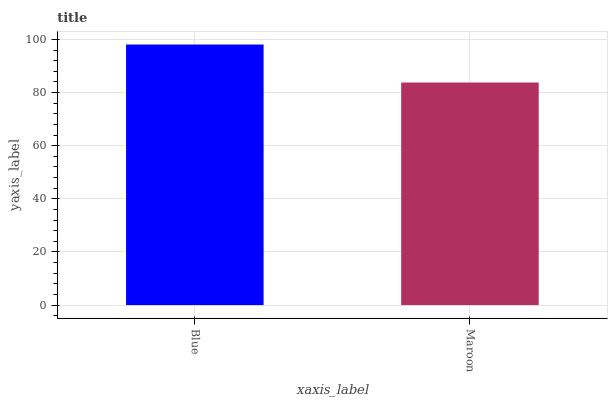Is Maroon the minimum?
Answer yes or no. Yes. Is Blue the maximum?
Answer yes or no. Yes. Is Maroon the maximum?
Answer yes or no. No. Is Blue greater than Maroon?
Answer yes or no. Yes. Is Maroon less than Blue?
Answer yes or no. Yes. Is Maroon greater than Blue?
Answer yes or no. No. Is Blue less than Maroon?
Answer yes or no. No. Is Blue the high median?
Answer yes or no. Yes. Is Maroon the low median?
Answer yes or no. Yes. Is Maroon the high median?
Answer yes or no. No. Is Blue the low median?
Answer yes or no. No. 